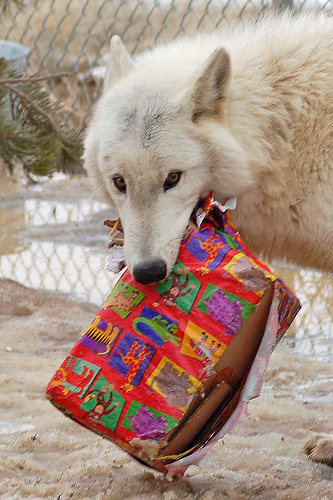<image>
Is there a wolf on the box? No. The wolf is not positioned on the box. They may be near each other, but the wolf is not supported by or resting on top of the box. Is there a tree behind the wolf? Yes. From this viewpoint, the tree is positioned behind the wolf, with the wolf partially or fully occluding the tree. Is there a dog in front of the present? No. The dog is not in front of the present. The spatial positioning shows a different relationship between these objects. 